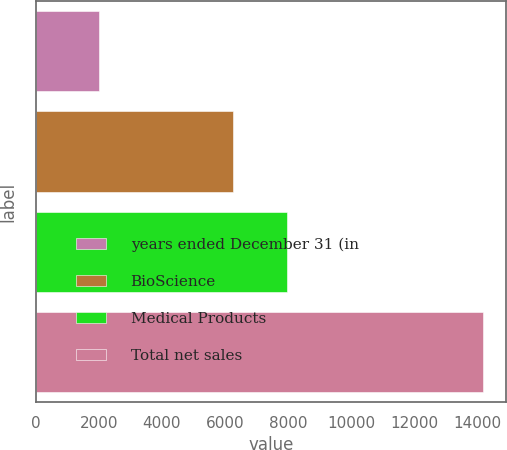Convert chart to OTSL. <chart><loc_0><loc_0><loc_500><loc_500><bar_chart><fcel>years ended December 31 (in<fcel>BioScience<fcel>Medical Products<fcel>Total net sales<nl><fcel>2012<fcel>6237<fcel>7953<fcel>14190<nl></chart> 